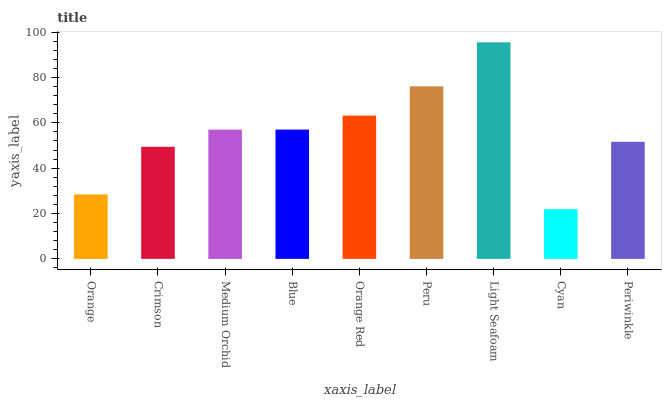Is Cyan the minimum?
Answer yes or no. Yes. Is Light Seafoam the maximum?
Answer yes or no. Yes. Is Crimson the minimum?
Answer yes or no. No. Is Crimson the maximum?
Answer yes or no. No. Is Crimson greater than Orange?
Answer yes or no. Yes. Is Orange less than Crimson?
Answer yes or no. Yes. Is Orange greater than Crimson?
Answer yes or no. No. Is Crimson less than Orange?
Answer yes or no. No. Is Medium Orchid the high median?
Answer yes or no. Yes. Is Medium Orchid the low median?
Answer yes or no. Yes. Is Peru the high median?
Answer yes or no. No. Is Orange Red the low median?
Answer yes or no. No. 